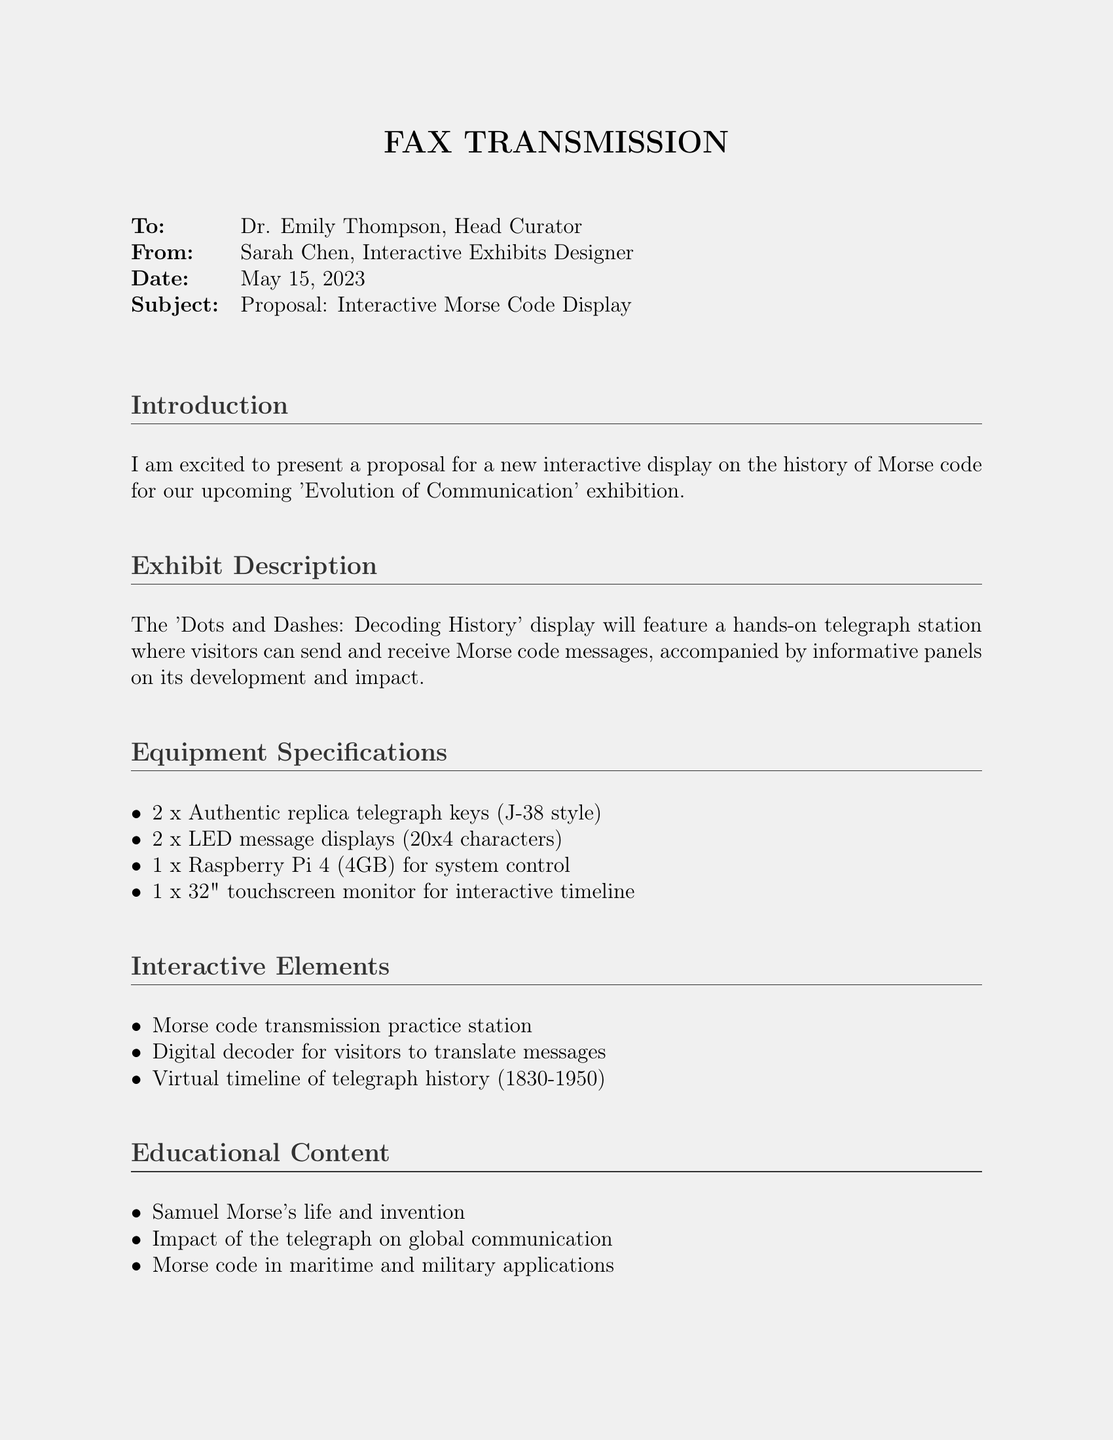What is the title of the proposal? The title is mentioned in the subject line of the fax as "Proposal: Interactive Morse Code Display."
Answer: Interactive Morse Code Display Who is the sender of the fax? The sender's name is listed at the top of the fax, identifying her as the Interactive Exhibits Designer.
Answer: Sarah Chen How many telegraph keys are included in the specifications? The number of telegraph keys is stated in the equipment specifications section.
Answer: 2 What is the total cost estimate for the display? The total cost is presented in a summary table at the end of the fax.
Answer: $14,000 What historical period does the virtual timeline cover? The virtual timeline’s coverage is specified in the interactive elements section of the document.
Answer: 1830-1950 What type of monitor is specified for the display? The type of monitor is described in the equipment specifications, highlighting its size and function.
Answer: 32" touchscreen monitor Which famous inventor's life is part of the educational content? The educational content includes notable figures, with a specific mention of one inventor.
Answer: Samuel Morse What is the installation cost listed in the proposal? The installation cost is provided alongside other cost estimates in the document.
Answer: $2,250 